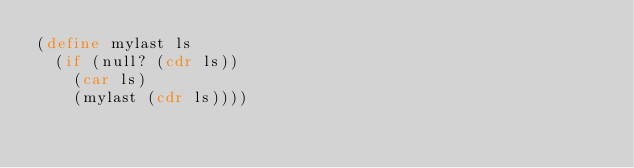<code> <loc_0><loc_0><loc_500><loc_500><_Scheme_>(define mylast ls
  (if (null? (cdr ls))
    (car ls)
    (mylast (cdr ls))))
</code> 